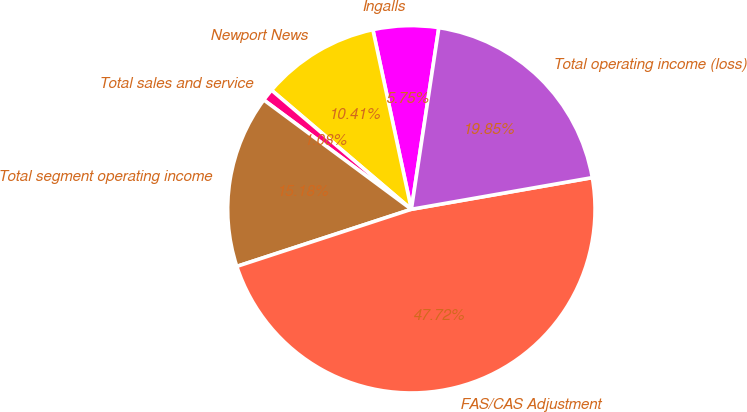Convert chart. <chart><loc_0><loc_0><loc_500><loc_500><pie_chart><fcel>Ingalls<fcel>Newport News<fcel>Total sales and service<fcel>Total segment operating income<fcel>FAS/CAS Adjustment<fcel>Total operating income (loss)<nl><fcel>5.75%<fcel>10.41%<fcel>1.08%<fcel>15.18%<fcel>47.72%<fcel>19.85%<nl></chart> 